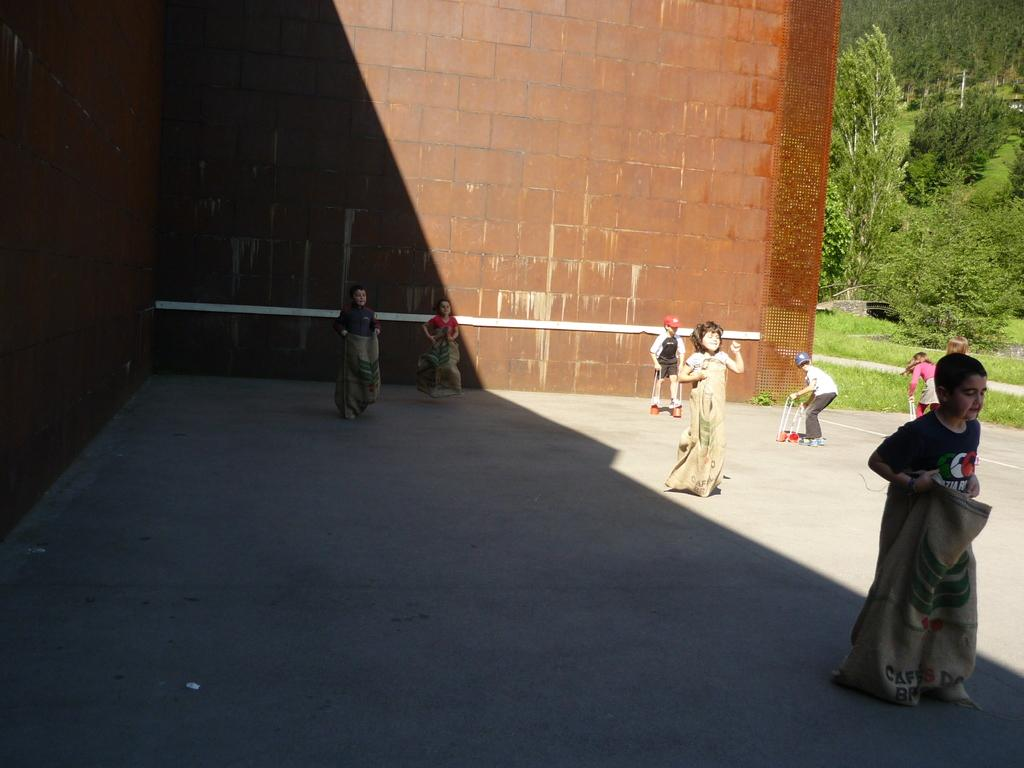What can be seen in the image? There are kids in the image. What are the kids holding? The kids are holding bags. What can be seen in the background of the image? There is a red wall, grass, and trees in the background of the image. What type of bell can be heard ringing in the image? There is no bell present in the image, and therefore no sound can be heard. 